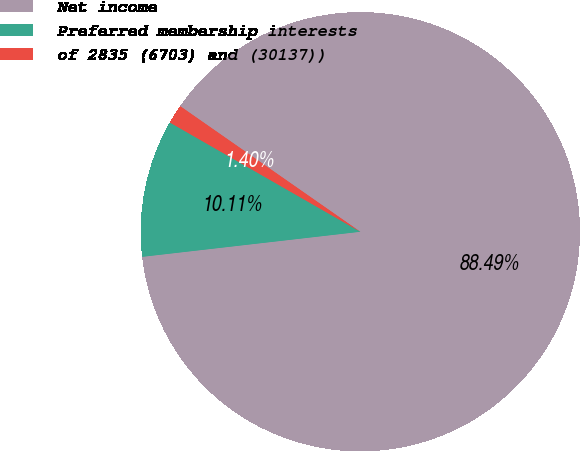<chart> <loc_0><loc_0><loc_500><loc_500><pie_chart><fcel>Net income<fcel>Preferred membership interests<fcel>of 2835 (6703) and (30137))<nl><fcel>88.49%<fcel>10.11%<fcel>1.4%<nl></chart> 